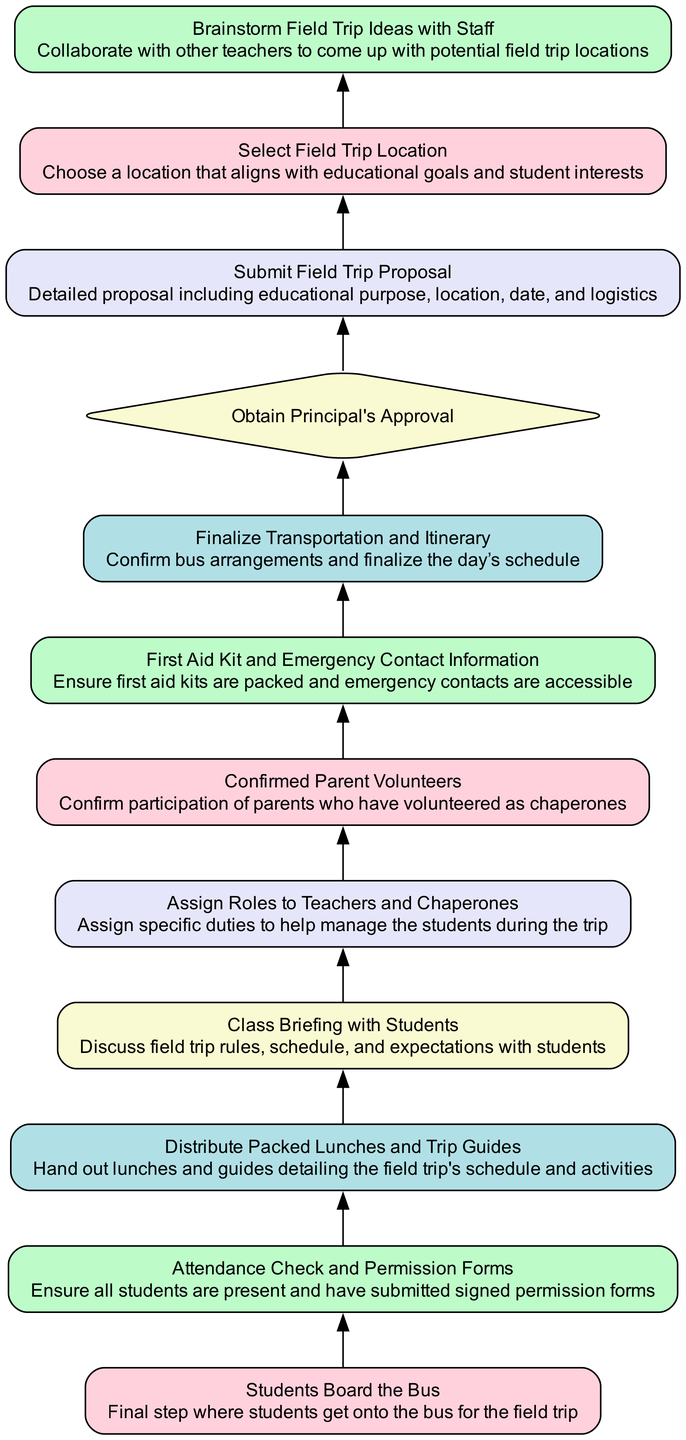What is the final step in the flowchart? The final step in the flowchart is "Students Board the Bus." This is the last action that takes place after all previous steps have been completed, marking the transition from preparation to the actual field trip event.
Answer: Students Board the Bus How many nodes are there in the diagram? The diagram contains twelve nodes in total, including both process nodes and decision nodes. Each represents a specific step or decision point in the field trip preparation process.
Answer: Twelve Which step involves confirming parent participation? The step that involves confirming parent participation is "Confirmed Parent Volunteers." This step ensures that all necessary parental chaperones are accounted for before the trip proceeds.
Answer: Confirmed Parent Volunteers What must happen before students can board the bus? Before students can board the bus, several steps must be completed, including "Attendance Check and Permission Forms," "Distribute Packed Lunches and Trip Guides," "Class Briefing with Students," and "Assign Roles to Teachers and Chaperones." These ensure that all preparations for the trip have been adequately made.
Answer: Attendance Check and Permission Forms, Distribute Packed Lunches and Trip Guides, Class Briefing with Students, Assign Roles to Teachers and Chaperones What decision must be made at step 8? The decision made at step 8 is “Obtain Principal's Approval.” This is a crucial checkpoint that ensures the field trip has received the necessary authorization from school administration.
Answer: Obtain Principal's Approval After “Submit Field Trip Proposal,” what is the next process? After "Submit Field Trip Proposal," the next process is "Obtain Principal's Approval." This indicates that the proposal must be approved by the principal before moving forward with further planning steps.
Answer: Obtain Principal's Approval Which step follows preparing emergency supplies? The step that follows "First Aid Kit and Emergency Contact Information" is "Finalize Transportation and Itinerary." This means that preparations for emergency situations lead directly into confirming logistics related to transportation and schedule for the trip.
Answer: Finalize Transportation and Itinerary What is the purpose of the "Class Briefing with Students"? The purpose of the "Class Briefing with Students" is to discuss field trip rules, schedule, and expectations, ensuring that all students are aware of what to expect and what is expected of them during the trip.
Answer: Discuss field trip rules, schedule, and expectations How many decision points are in the diagram? There is one decision point in the diagram, which is "Obtain Principal's Approval." This is where a critical decision regarding the continuation of the field trip planning process is made.
Answer: One 